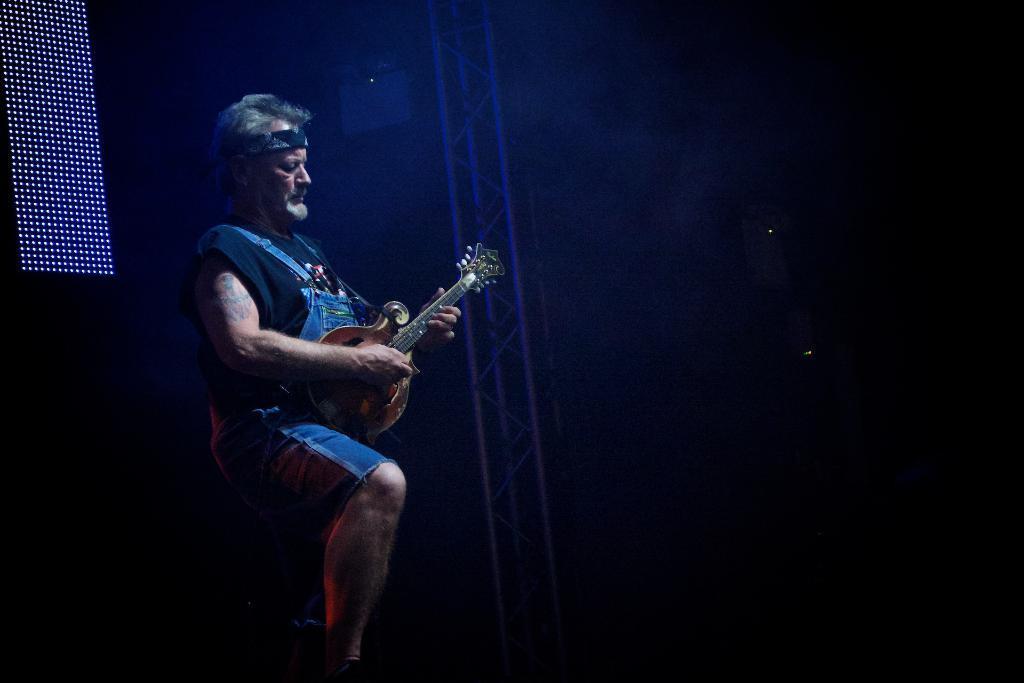Can you describe this image briefly? In this image i can see a man is playing a guitar in his hand. 